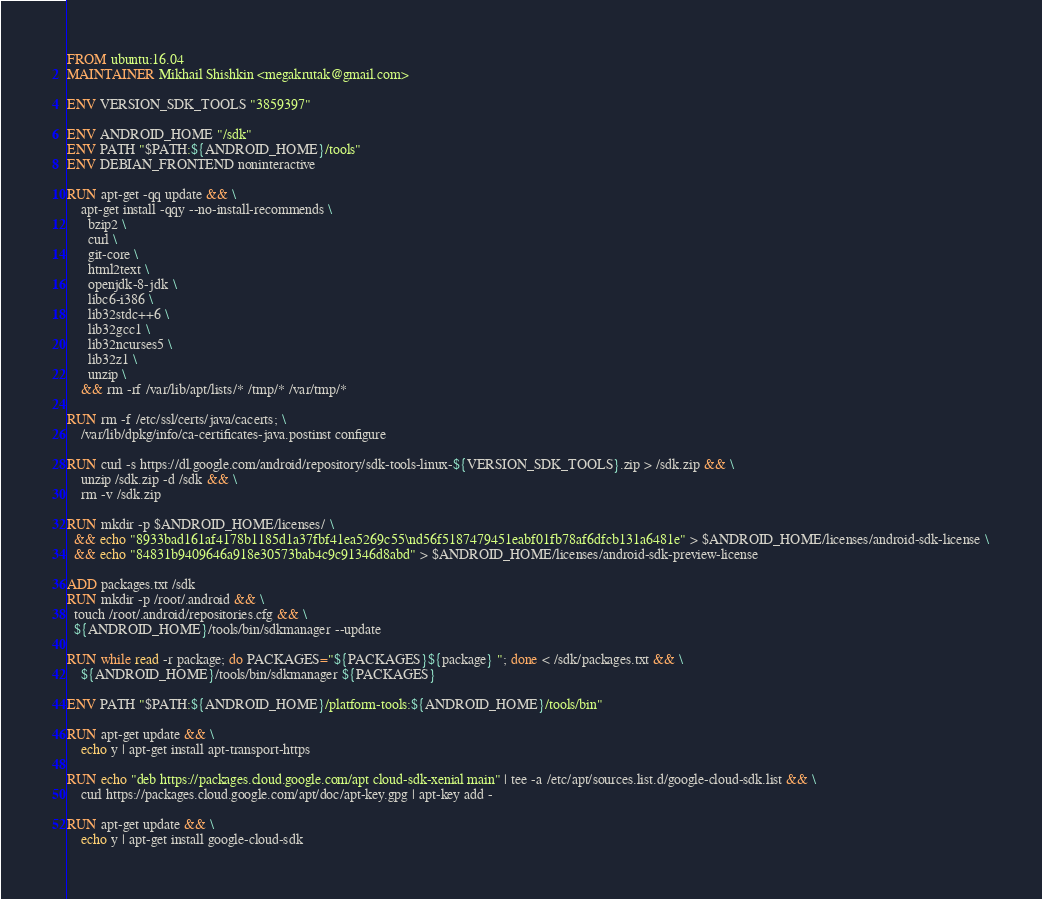<code> <loc_0><loc_0><loc_500><loc_500><_Dockerfile_>FROM ubuntu:16.04
MAINTAINER Mikhail Shishkin <megakrutak@gmail.com>

ENV VERSION_SDK_TOOLS "3859397"

ENV ANDROID_HOME "/sdk"
ENV PATH "$PATH:${ANDROID_HOME}/tools"
ENV DEBIAN_FRONTEND noninteractive

RUN apt-get -qq update && \
    apt-get install -qqy --no-install-recommends \
      bzip2 \
      curl \
      git-core \
      html2text \
      openjdk-8-jdk \
      libc6-i386 \
      lib32stdc++6 \
      lib32gcc1 \
      lib32ncurses5 \
      lib32z1 \
      unzip \
    && rm -rf /var/lib/apt/lists/* /tmp/* /var/tmp/*

RUN rm -f /etc/ssl/certs/java/cacerts; \
    /var/lib/dpkg/info/ca-certificates-java.postinst configure

RUN curl -s https://dl.google.com/android/repository/sdk-tools-linux-${VERSION_SDK_TOOLS}.zip > /sdk.zip && \
    unzip /sdk.zip -d /sdk && \
    rm -v /sdk.zip

RUN mkdir -p $ANDROID_HOME/licenses/ \
  && echo "8933bad161af4178b1185d1a37fbf41ea5269c55\nd56f5187479451eabf01fb78af6dfcb131a6481e" > $ANDROID_HOME/licenses/android-sdk-license \
  && echo "84831b9409646a918e30573bab4c9c91346d8abd" > $ANDROID_HOME/licenses/android-sdk-preview-license

ADD packages.txt /sdk
RUN mkdir -p /root/.android && \
  touch /root/.android/repositories.cfg && \
  ${ANDROID_HOME}/tools/bin/sdkmanager --update 

RUN while read -r package; do PACKAGES="${PACKAGES}${package} "; done < /sdk/packages.txt && \
    ${ANDROID_HOME}/tools/bin/sdkmanager ${PACKAGES}
    
ENV PATH "$PATH:${ANDROID_HOME}/platform-tools:${ANDROID_HOME}/tools/bin"

RUN apt-get update && \
    echo y | apt-get install apt-transport-https

RUN echo "deb https://packages.cloud.google.com/apt cloud-sdk-xenial main" | tee -a /etc/apt/sources.list.d/google-cloud-sdk.list && \
    curl https://packages.cloud.google.com/apt/doc/apt-key.gpg | apt-key add -

RUN apt-get update && \
    echo y | apt-get install google-cloud-sdk
</code> 